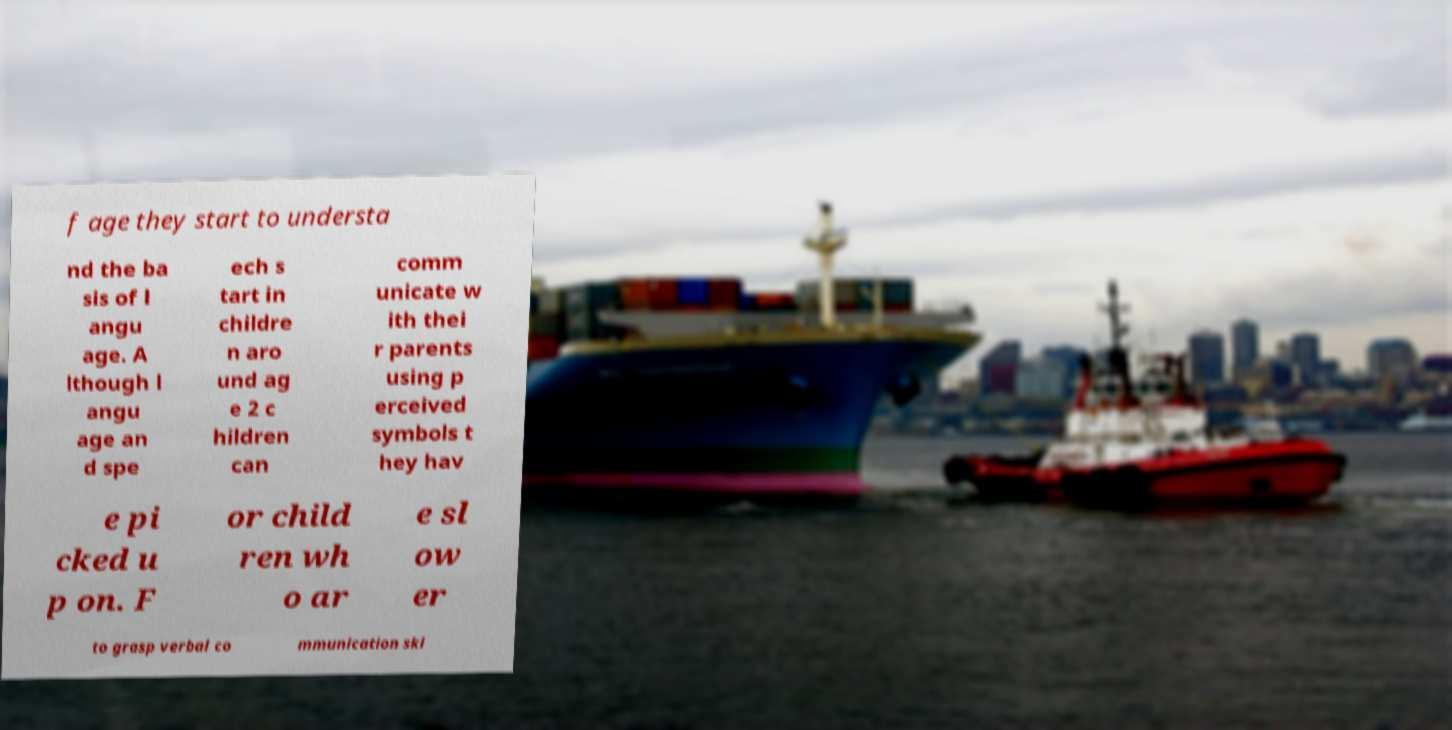Please identify and transcribe the text found in this image. f age they start to understa nd the ba sis of l angu age. A lthough l angu age an d spe ech s tart in childre n aro und ag e 2 c hildren can comm unicate w ith thei r parents using p erceived symbols t hey hav e pi cked u p on. F or child ren wh o ar e sl ow er to grasp verbal co mmunication ski 